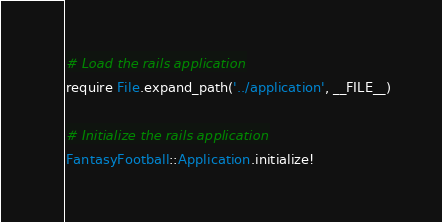<code> <loc_0><loc_0><loc_500><loc_500><_Ruby_># Load the rails application
require File.expand_path('../application', __FILE__)

# Initialize the rails application
FantasyFootball::Application.initialize!
</code> 